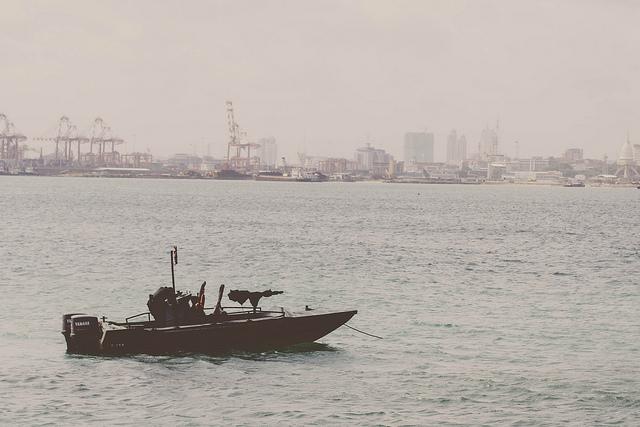What furthest away from the camera?
Concise answer only. Buildings. Is the boat in the water?
Be succinct. Yes. Is it sunny?
Keep it brief. No. How would you describe the visibility conditions?
Give a very brief answer. Foggy. Is the boat moving?
Short answer required. Yes. How many boats are visible?
Concise answer only. 1. Is the boat going towards the shore?
Write a very short answer. No. How does the boat move?
Concise answer only. Motor. 